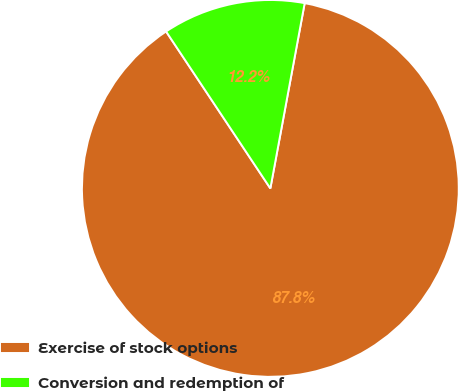Convert chart to OTSL. <chart><loc_0><loc_0><loc_500><loc_500><pie_chart><fcel>Exercise of stock options<fcel>Conversion and redemption of<nl><fcel>87.75%<fcel>12.25%<nl></chart> 